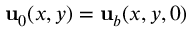<formula> <loc_0><loc_0><loc_500><loc_500>u _ { 0 } ( x , y ) = u _ { b } ( x , y , 0 )</formula> 